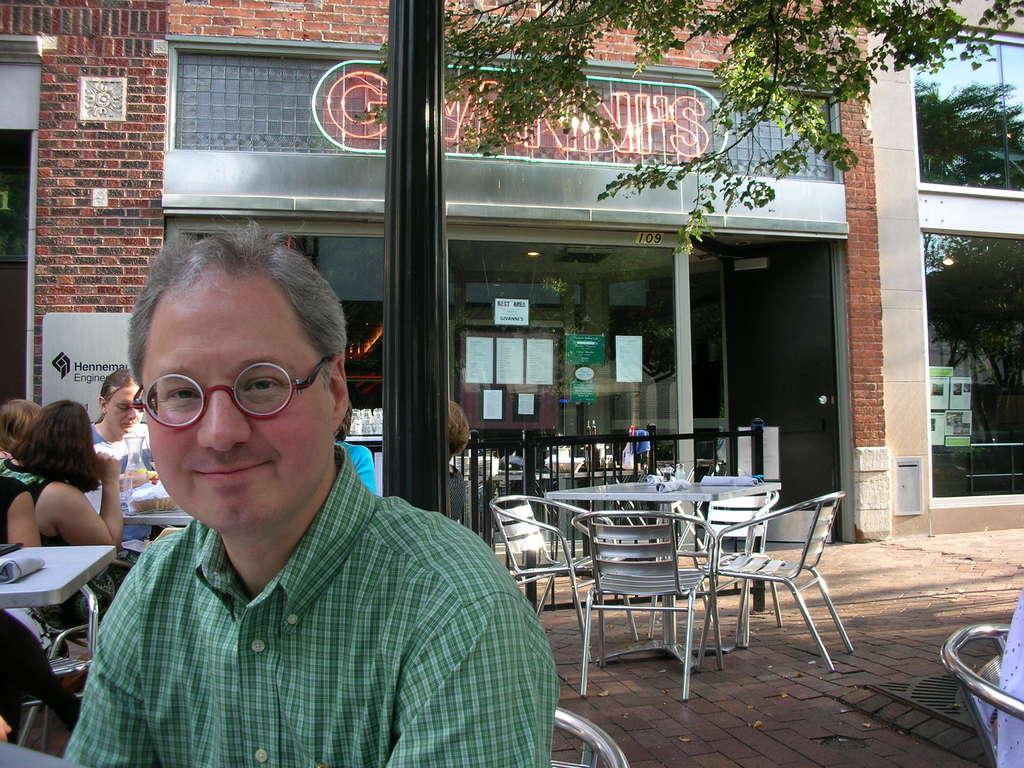Can you describe this image briefly? In this image I can see few people are sitting on chairs. Here I can see he is wearing a specs and also smile on his face. In the background I can see few more chairs and tables. 